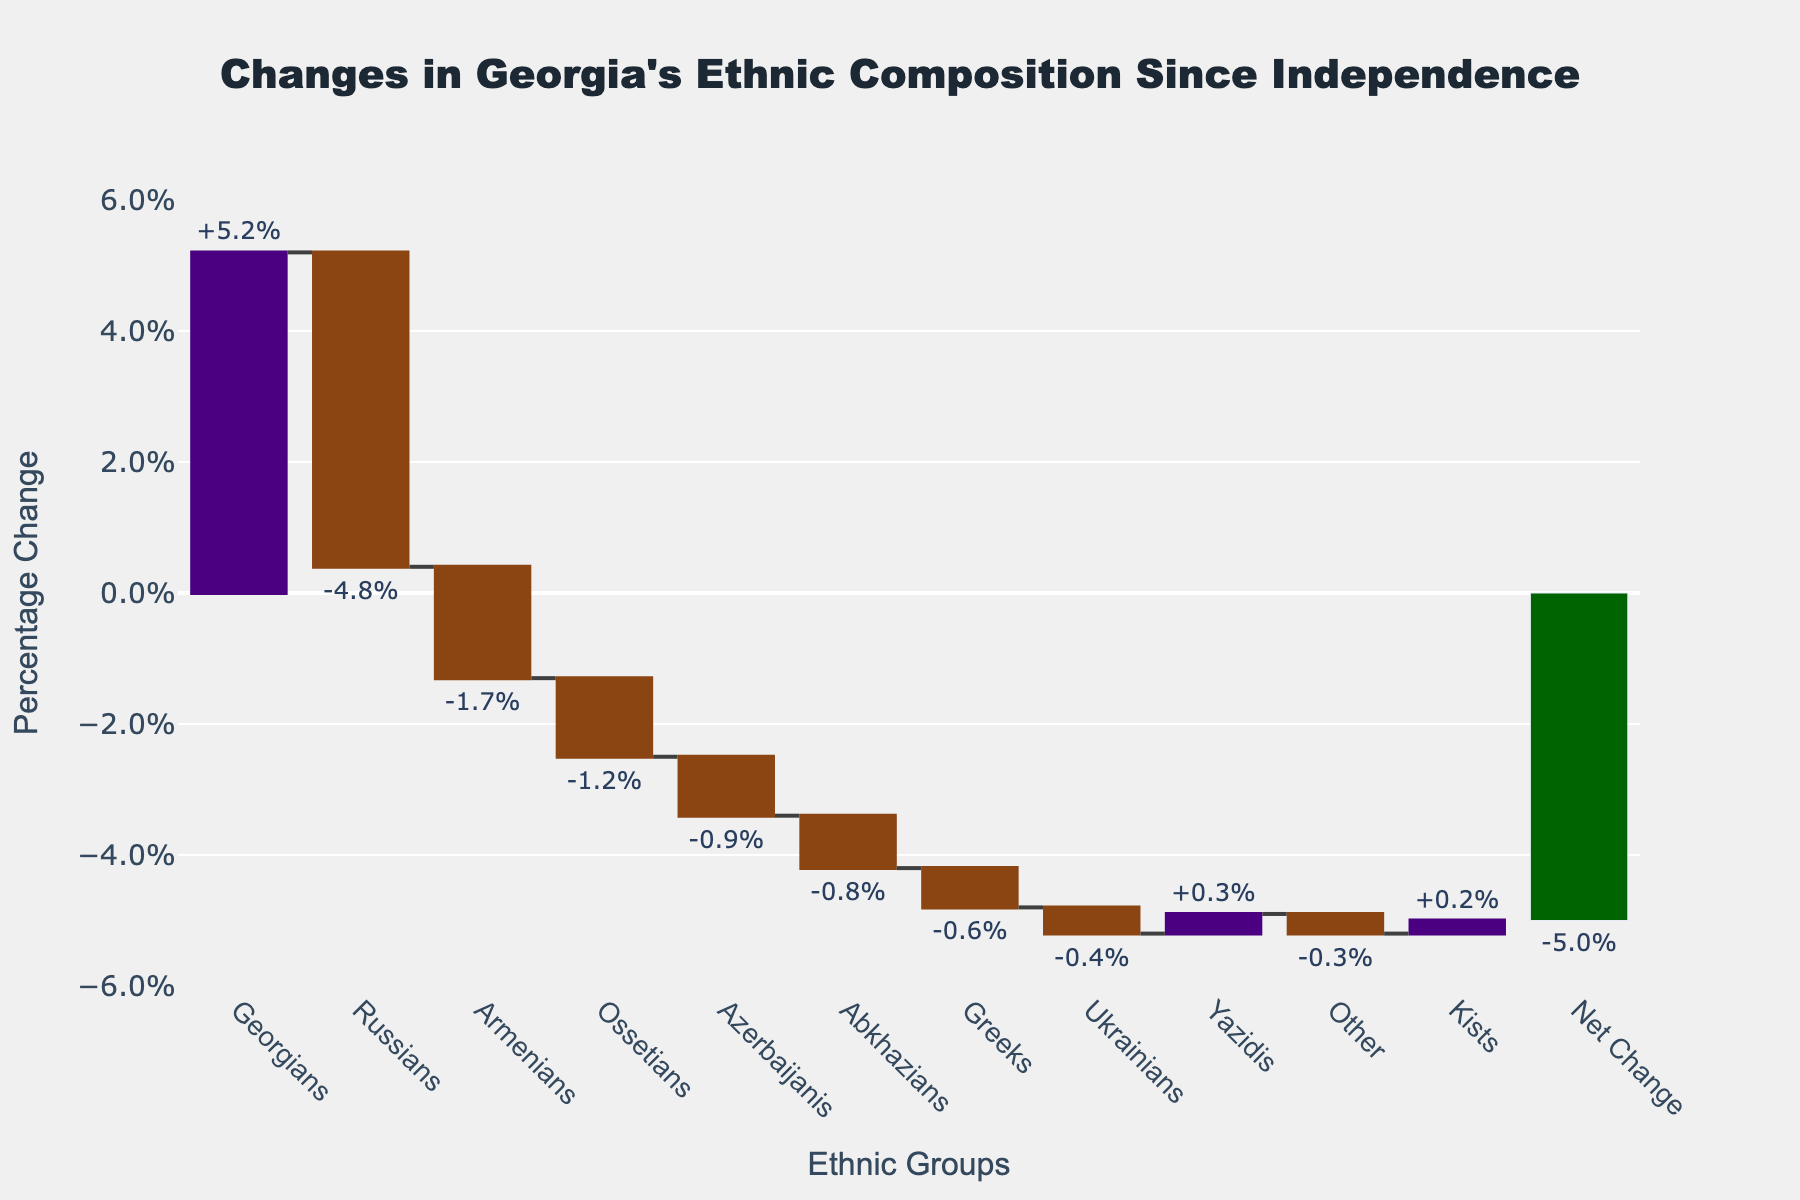What is the title of the chart? The title is displayed at the top of the chart, showing a descriptive text about the data presented.
Answer: Changes in Georgia's Ethnic Composition Since Independence Which ethnic group has seen the largest increase in percentage? By observing the chart, the ethnic group with the tallest bar in the positive direction (color for increasing segments) indicates the largest increase.
Answer: Georgians What is the percentage change for Russians? Find the label for Russians on the x-axis and observe the value indicated by the bar in the negative direction.
Answer: -4.8% How many ethnic groups have decreased in percentage since independence? Count the number of negative values on the chart.
Answer: 7 What is the total net change in ethnic composition? Locate the final bar labeled 'Net Change' which combines all the positive and negative changes.
Answer: -4.8% Which two ethnic groups have the smallest changes, and what are their percentages? Identify the shortest bars in both the positive and negative directions and note the values.
Answer: Kists (+0.2%), Greeks (-0.6%) Compare the percentage change between Armenians and Azerbaijanis. Which group had a larger decrease? Compare the negative values for Armenians and Azerbaijanis.
Answer: Armenians (-1.7%) What is the percentage change sum of the four ethnic groups with the largest increases? Sum the top four positive percentage changes.
Answer: 5.7% (Georgians +5.2%, Yazidis +0.3%, Kists +0.2% +0% from no other groups) What is the average percentage change among all ethnic groups displayed? Sum all listed percentage changes and divide by the number of ethnic groups.
Answer: -0.2% If only the ethnic groups with a positive change are considered, what would be the net change? Sum the percentages of all groups with positive changes.
Answer: +5.7% 